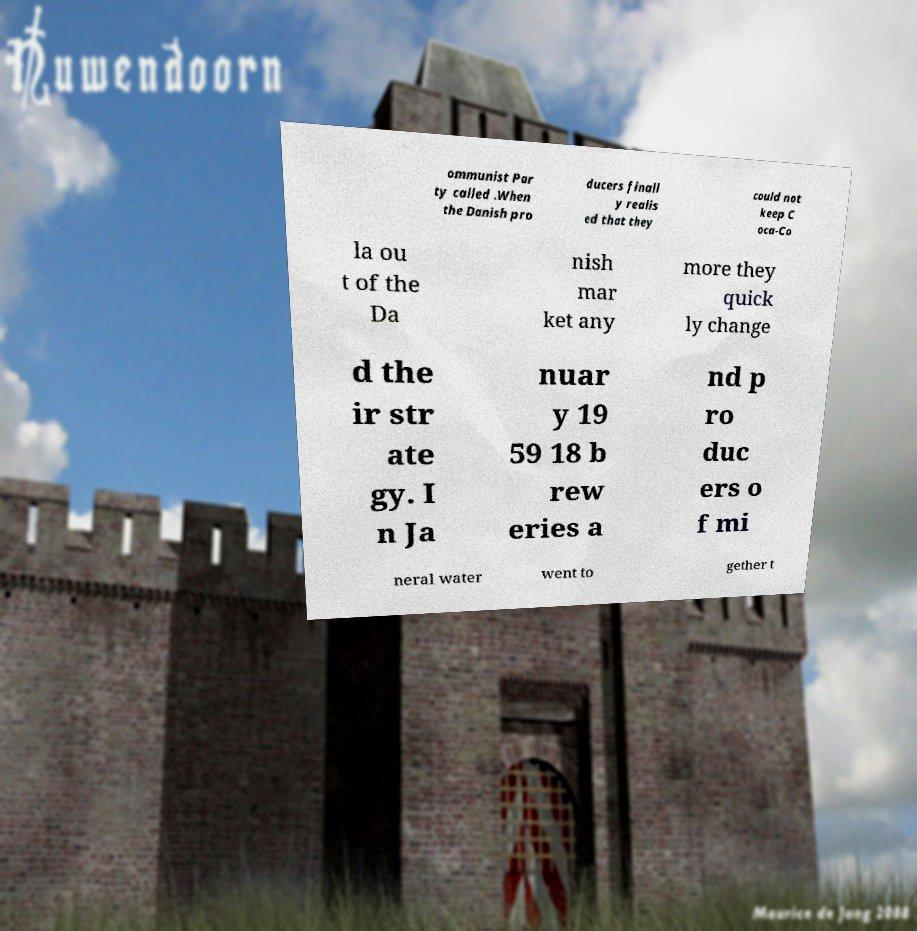For documentation purposes, I need the text within this image transcribed. Could you provide that? ommunist Par ty called .When the Danish pro ducers finall y realis ed that they could not keep C oca-Co la ou t of the Da nish mar ket any more they quick ly change d the ir str ate gy. I n Ja nuar y 19 59 18 b rew eries a nd p ro duc ers o f mi neral water went to gether t 